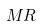Convert formula to latex. <formula><loc_0><loc_0><loc_500><loc_500>M R</formula> 